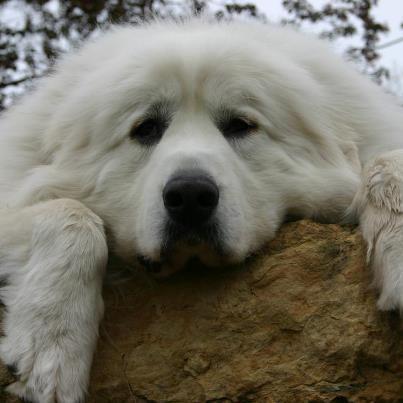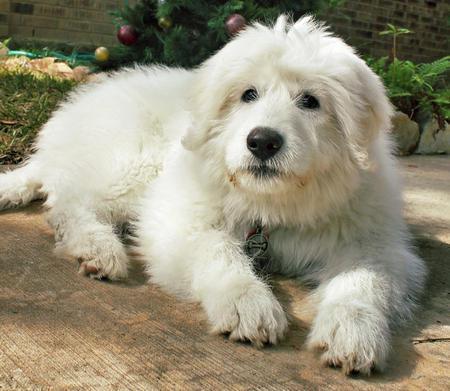The first image is the image on the left, the second image is the image on the right. Assess this claim about the two images: "A dog is lying on all fours with its head up in the air.". Correct or not? Answer yes or no. Yes. The first image is the image on the left, the second image is the image on the right. Analyze the images presented: Is the assertion "An image shows a white dog standing still, its body in profile." valid? Answer yes or no. No. 